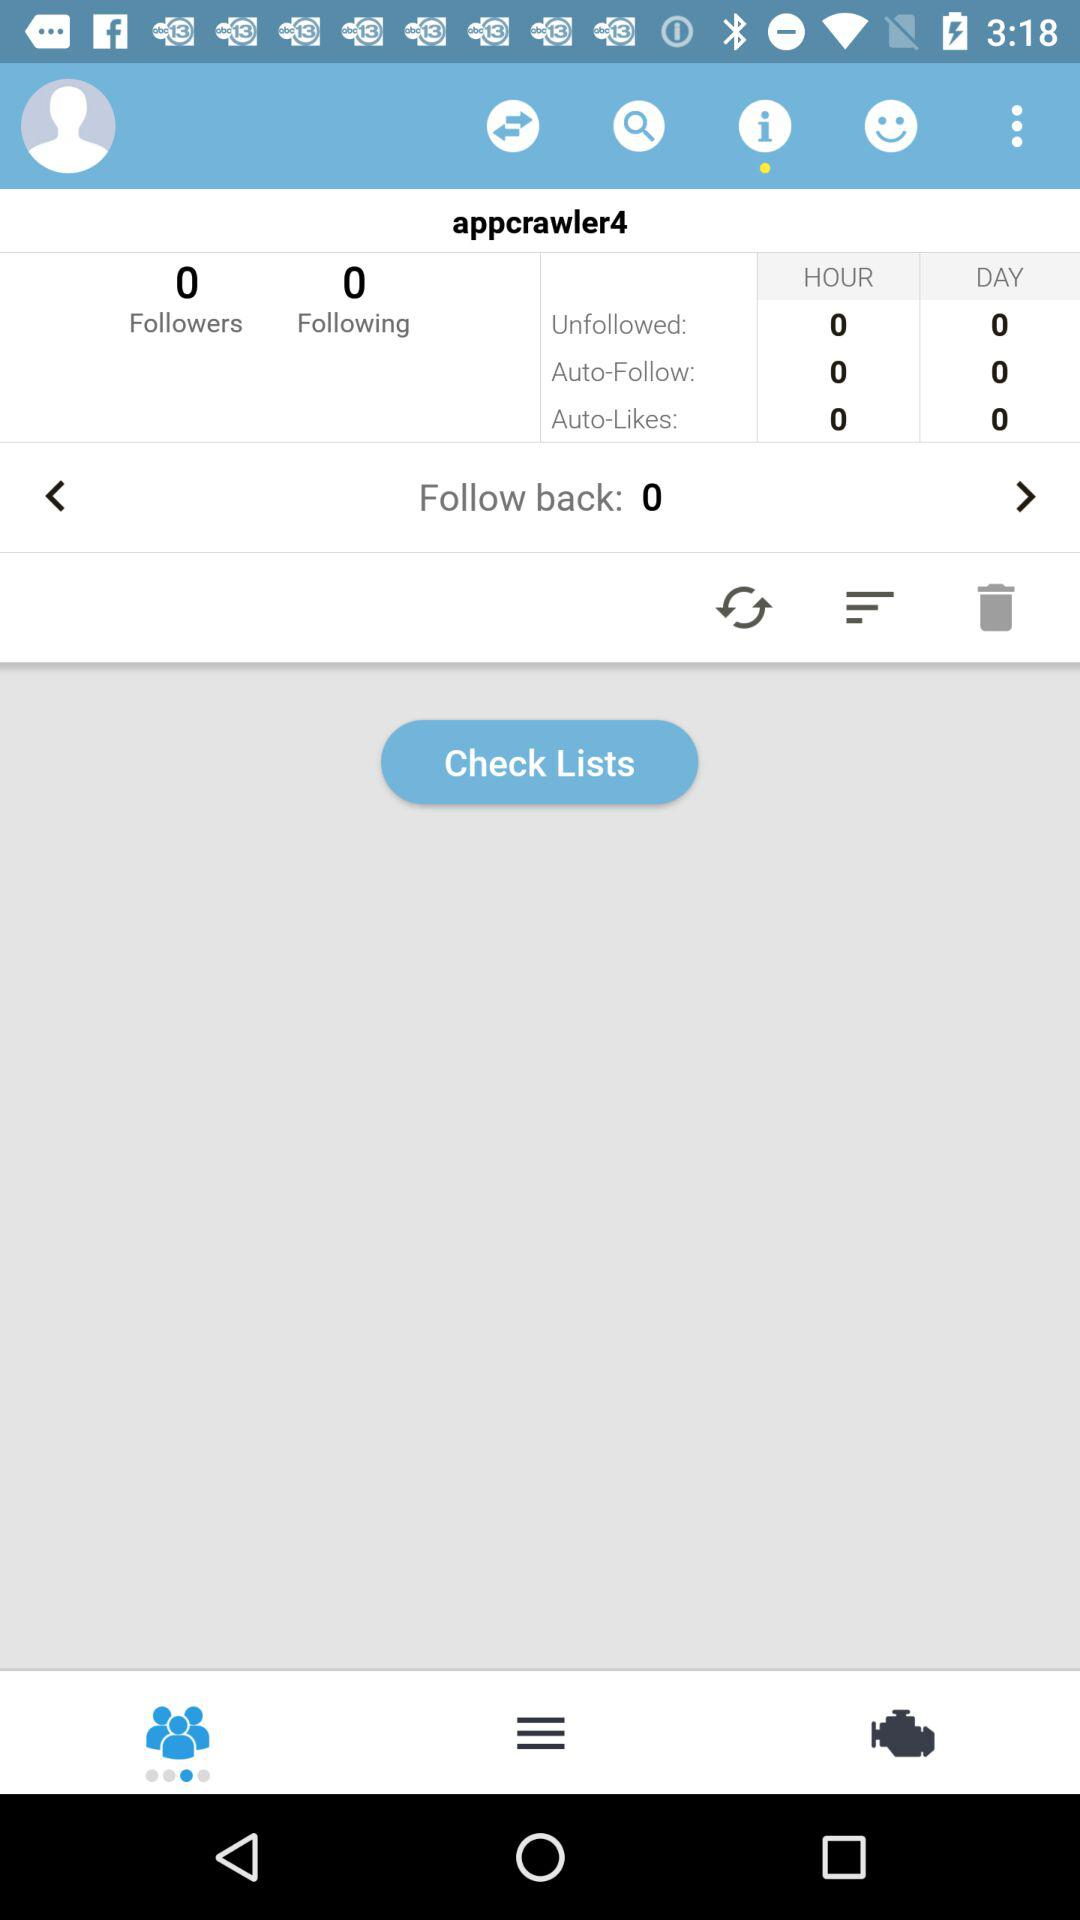How many people have followed back? The number of people who followed back is 0. 